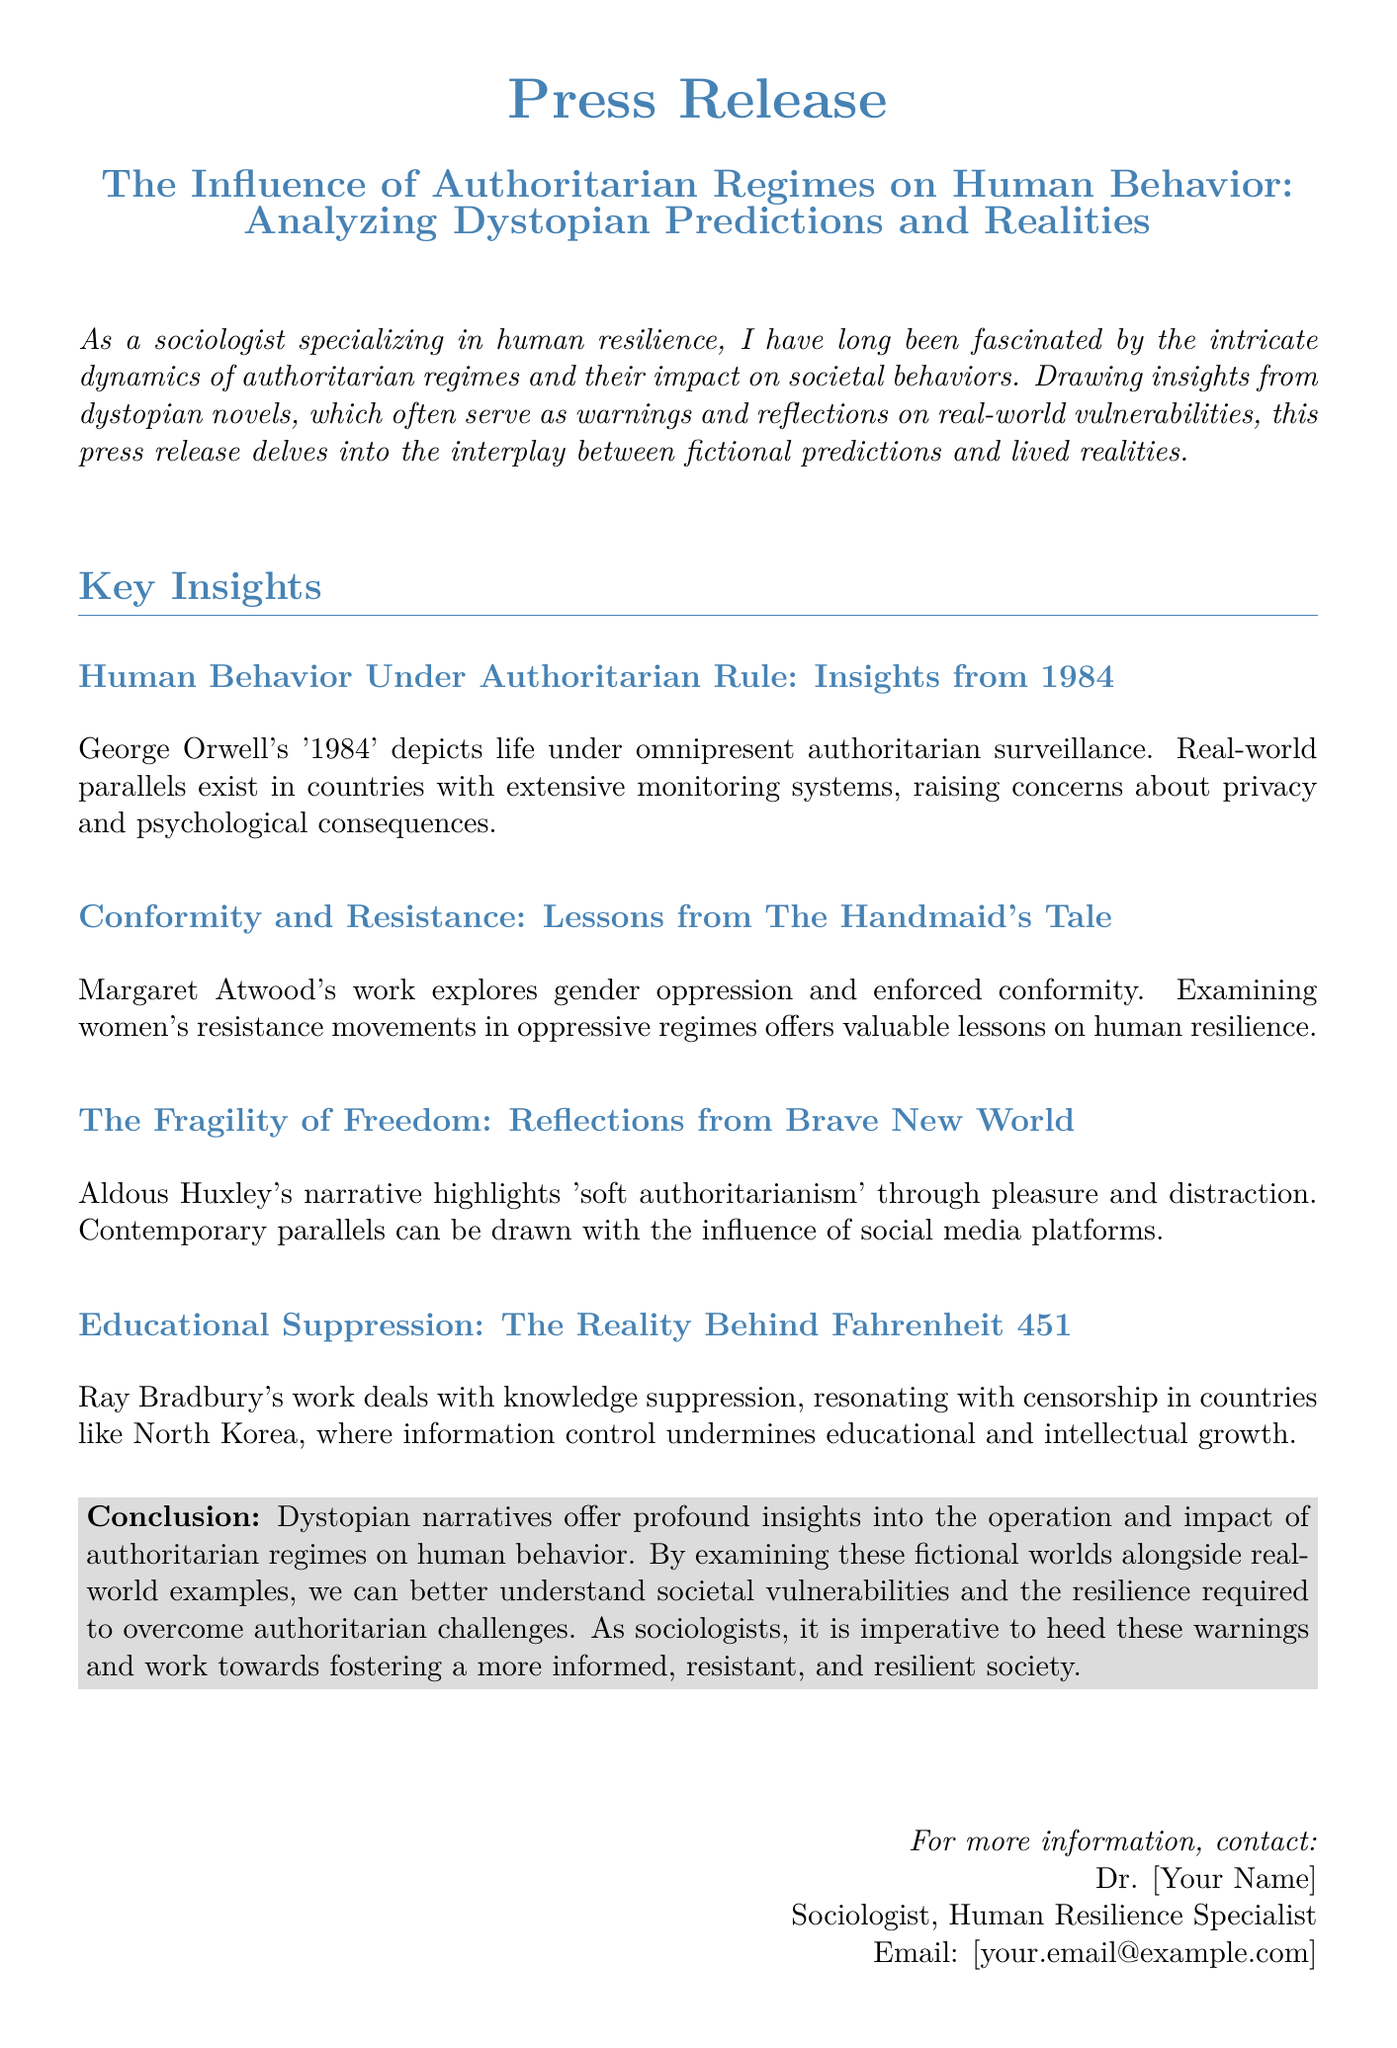What is the title of the press release? The title of the press release is the main heading presented at the top.
Answer: The Influence of Authoritarian Regimes on Human Behavior: Analyzing Dystopian Predictions and Realities Who is the author of '1984'? The author of '1984' is mentioned as a significant reference in the document.
Answer: George Orwell What societal theme is explored in The Handmaid's Tale? The document mentions the theme addressed in Margaret Atwood's work regarding societal behavior under oppressive conditions.
Answer: Gender oppression Which dystopian novel highlights 'soft authoritarianism'? The document specifically names the novel that represents this concept.
Answer: Brave New World What major issue does Fahrenheit 451 address? The document highlights a specific problem that the novel illustrates about knowledge and information.
Answer: Knowledge suppression What is the conclusion regarding dystopian narratives? The conclusion summarizes the overall message about the relevance of these narratives to real-world behavior.
Answer: Offer profound insights How does the press release categorize the themes from the novels? The press release organizes its findings into specific sections, indicating a structured approach.
Answer: Key Insights What is the role of Dr. [Your Name]? The press release lists Dr. [Your Name]'s professional title, indicating their expertise related to the document's topic.
Answer: Sociologist, Human Resilience Specialist 